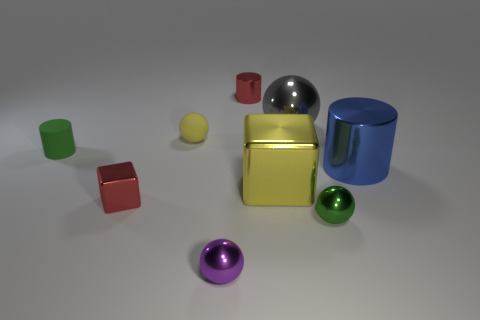How big is the rubber object to the right of the shiny block to the left of the yellow object that is in front of the yellow ball?
Your answer should be compact. Small. There is a green cylinder that is the same size as the yellow ball; what is it made of?
Your answer should be very brief. Rubber. Is there a blue cylinder of the same size as the gray sphere?
Provide a succinct answer. Yes. There is a green thing that is to the right of the yellow shiny block; is its size the same as the large cube?
Your response must be concise. No. What is the shape of the metallic thing that is both left of the big metallic ball and behind the big blue metal thing?
Keep it short and to the point. Cylinder. Is the number of cylinders that are on the right side of the tiny green shiny sphere greater than the number of gray things?
Your response must be concise. No. The green object that is made of the same material as the large yellow block is what size?
Your answer should be compact. Small. How many big metal cubes have the same color as the large metal sphere?
Ensure brevity in your answer.  0. There is a large thing that is behind the blue cylinder; is it the same color as the matte sphere?
Make the answer very short. No. Are there the same number of rubber spheres in front of the blue cylinder and purple metal spheres in front of the red shiny cylinder?
Offer a terse response. No. 